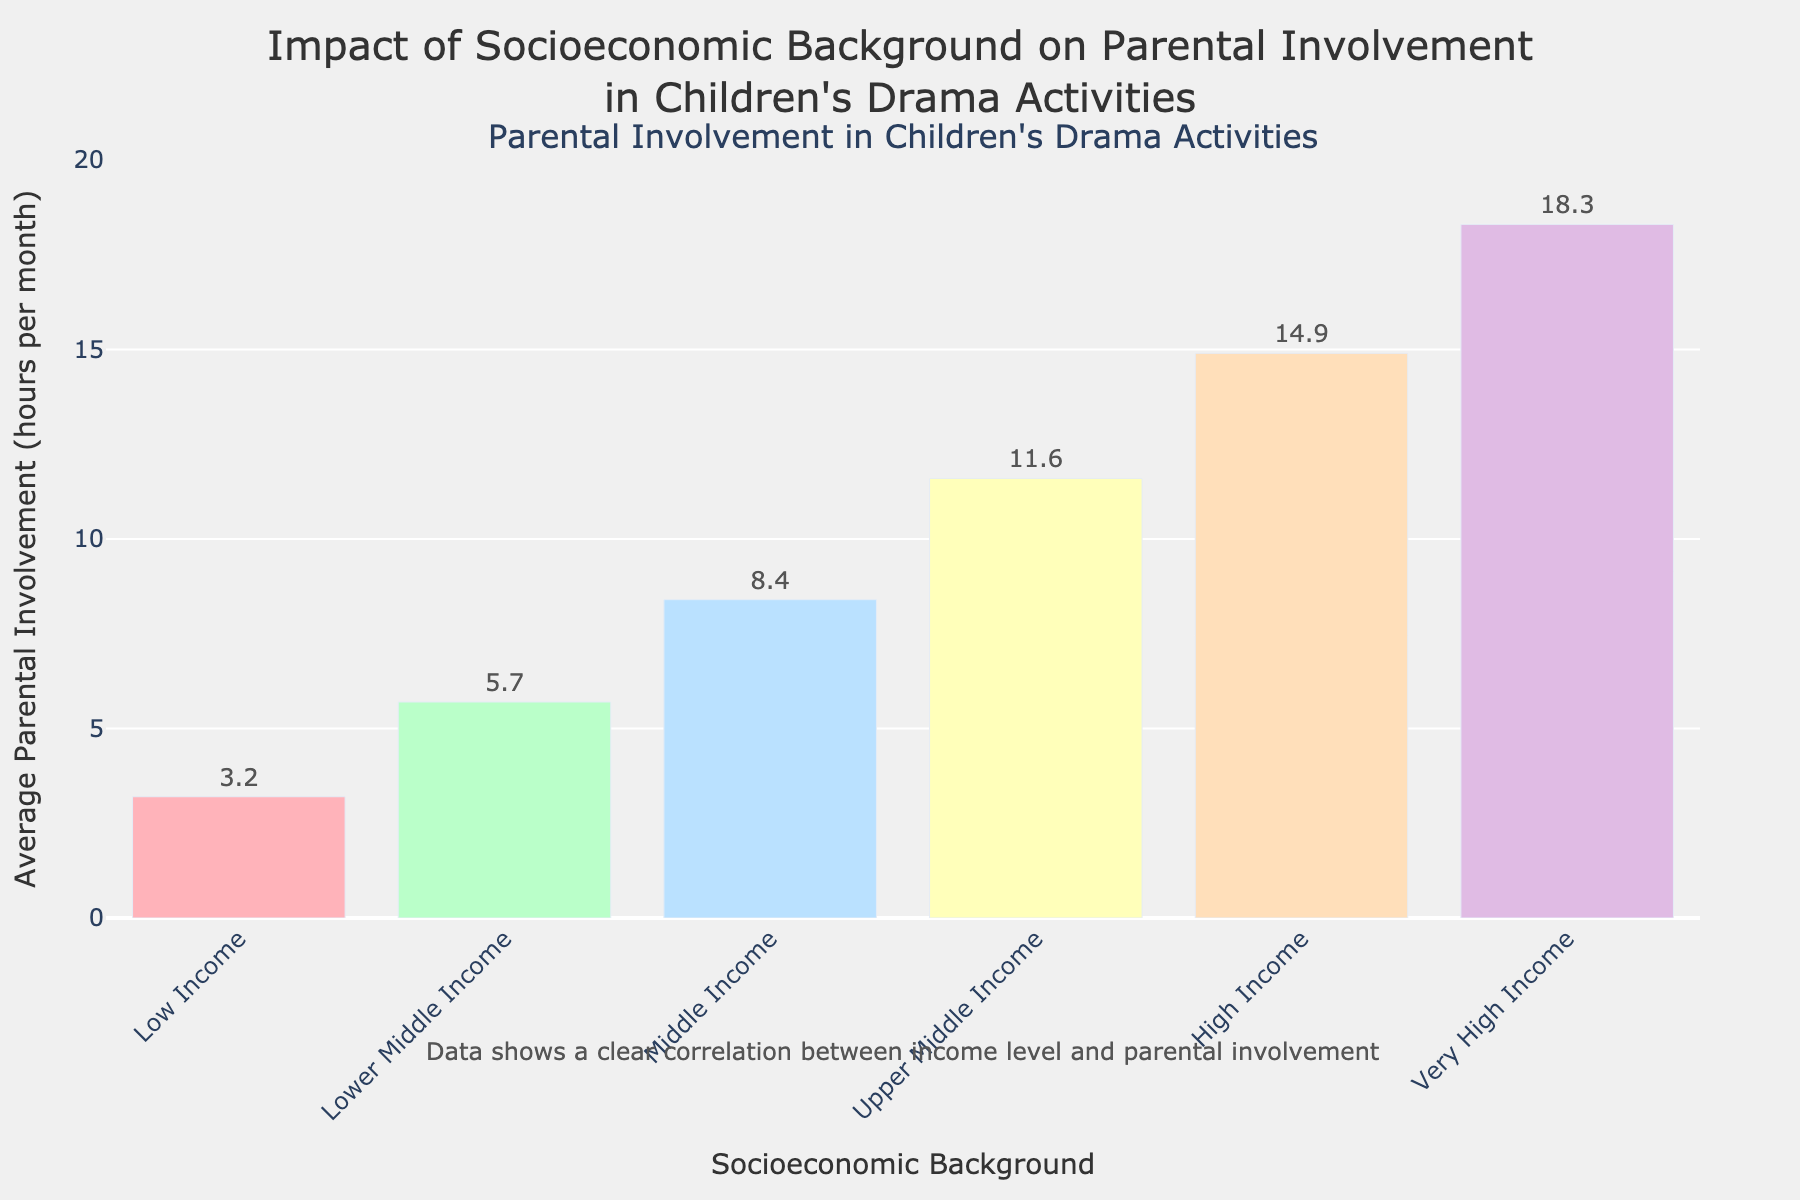Which socioeconomic background shows the highest average parental involvement? Look at the bar with the tallest height, which corresponds to the Very High Income group, displaying an average parental involvement of 18.3 hours per month.
Answer: Very High Income What is the difference in average parental involvement between the Low Income and High Income groups? Subtract the average involvement of the Low Income group (3.2 hours) from the High Income group (14.9 hours). This yields 14.9 - 3.2 = 11.7 hours.
Answer: 11.7 hours Which group has less average parental involvement, Lower Middle Income or Upper Middle Income? Compare the heights of the bars corresponding to these two groups. The Lower Middle Income bar represents 5.7 hours, which is less than the Upper Middle Income's 11.6 hours.
Answer: Lower Middle Income What is the combined average parental involvement for the Low and Lower Middle Income groups? Add the average involvement of the Low Income group (3.2 hours) to the Lower Middle Income group (5.7 hours). This results in 3.2 + 5.7 = 8.9 hours.
Answer: 8.9 hours How many more hours do parents from the Middle Income group spend on average than those from the Upper Middle Income group? Subtract the Upper Middle Income group's average involvement (11.6 hours) from the Middle Income group's (8.4 hours). This yields 11.6 - 8.4 = 3.2 hours.
Answer: 3.2 hours What is the average parental involvement (in hours) for all groups combined? Sum the average involvement times for all income groups (3.2, 5.7, 8.4, 11.6, 14.9, and 18.3) and divide by the number of groups (6). This yields (3.2 + 5.7 + 8.4 + 11.6 + 14.9 + 18.3)/6 = 62.1/6 ≈ 10.35 hours.
Answer: 10.35 hours Visually, which group’s bar is the closest to 10 hours of average parental involvement? Identify the bar visually closest to the 10-hour mark. The Middle Income group's bar, at approximately 8.4 hours, is the closest.
Answer: Middle Income What is the ratio of the average parental involvement of the Very High Income group to the Low Income group? Divide the Very High Income group's average involvement (18.3 hours) by the Low Income group's (3.2 hours). This yields 18.3/3.2 ≈ 5.72.
Answer: 5.72 